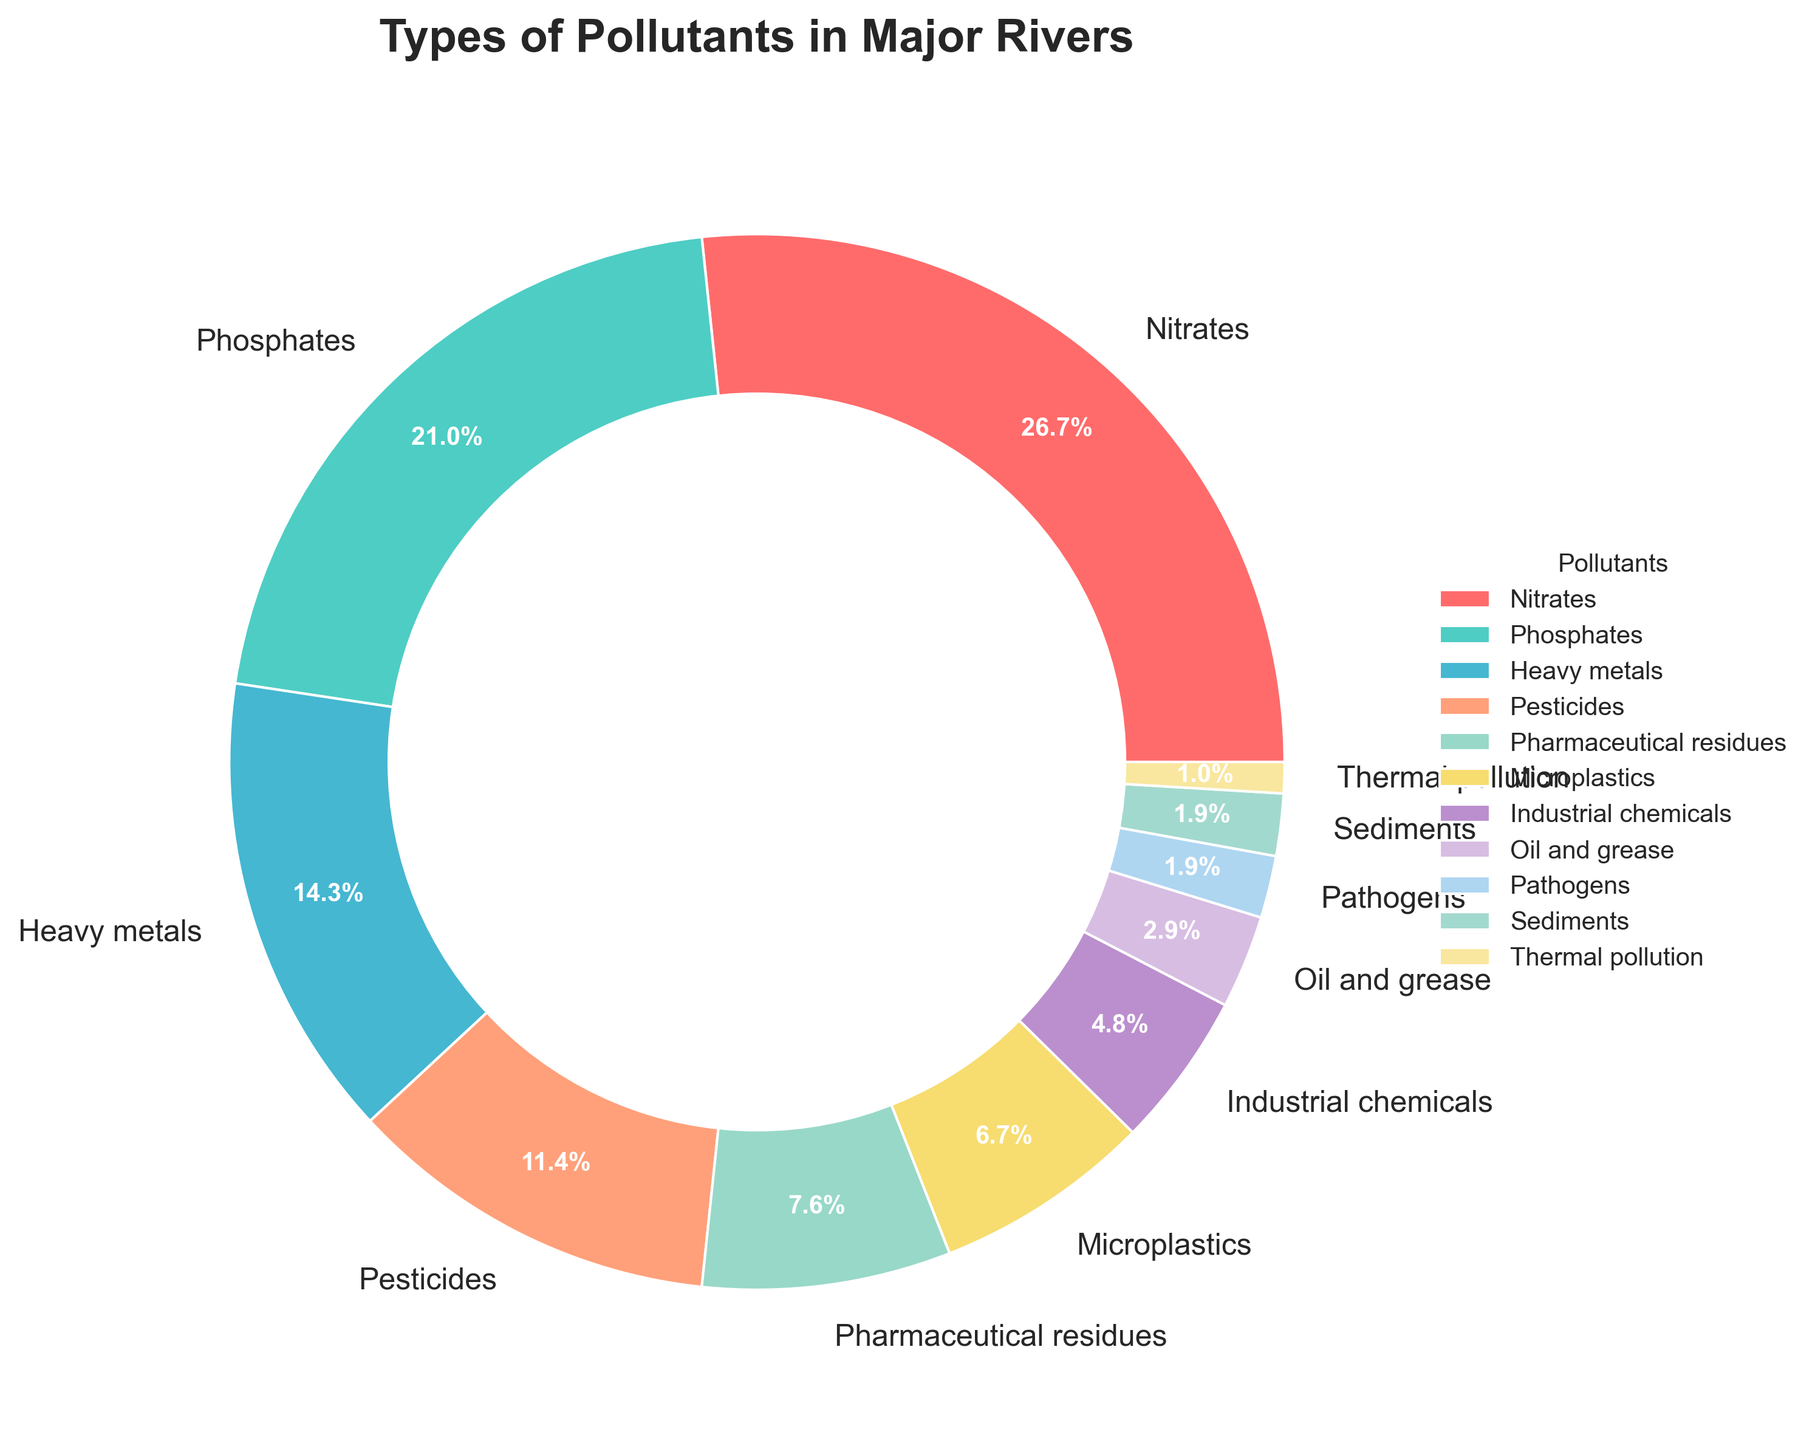What is the most common type of pollutant found in major rivers? The largest segment of the pie chart represents Nitrates with 28%. Hence, Nitrates are the most common pollutant.
Answer: Nitrates Which type of pollutants make up more than 20% individually? From the pie chart, Nitrates (28%) and Phosphates (22%) both have segments exceeding 20%.
Answer: Nitrates, Phosphates How much more prevalent are Nitrates compared to Pathogens? Nitrates comprise 28% and Pathogens comprise 2%. The difference is 28 - 2 = 26%.
Answer: 26% What are the combined percentages of Pesticides, Microplastics, and Industrial chemicals? Adding the percentages: Pesticides (12%) + Microplastics (7%) + Industrial chemicals (5%) = 12 + 7 + 5 = 24%.
Answer: 24% Which pollutants have a percentage less than Oil and Grease? Oil and Grease account for 3%. The pollutants with less than 3% are Pathogens (2%), Sediments (2%), and Thermal pollution (1%).
Answer: Pathogens, Sediments, Thermal pollution Are there more Industrial chemicals or Heavy metals present in the rivers? Industrial chemicals constitute 5% while Heavy metals make up 15%. Therefore, there are more Heavy metals.
Answer: Heavy metals What percentage of pollutants comes from pharmaceutical residues and microplastics combined? Adding the percentages: Pharmaceutical residues (8%) + Microplastics (7%) = 8 + 7 = 15%.
Answer: 15% How does the prevalence of Phosphates compare to that of Heavy metals? Phosphates make up 22% and Heavy metals constitute 15%. Hence, Phosphates are more prevalent by 7%.
Answer: Phosphates What is the cumulative percentage of the three least common pollutants? The three least common pollutants are Sediments (2%), Pathogens (2%), and Thermal pollution (1%). Their cumulative percentage is 2 + 2 + 1 = 5%.
Answer: 5% Which slice in the pie chart is colored red? The red color slice corresponds to Nitrates, which represents the most common pollutant at 28%.
Answer: Nitrates 